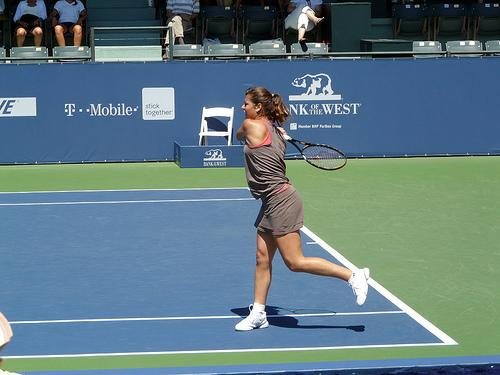Provide three details about the tennis player's outfit. The tennis player is wearing a gray tank top, a gray short skirt, and white shoes with white socks. Mention three different colors visible on the tennis court's surface. Blue, green, and white are colors visible on the tennis court's surface. Explain the natural phenomenon creating a specific feature in the picture that indicates the presence of the main character. A shadow of the woman is created due to the sunlight hitting her and being obstructed, resulting in a darker area on the ground. Describe the condition of the seating area in the image. There are spectators in the bleachers, some empty blue seats, a white folding chair, and front row seats with people watching the tennis match.  Describe the actions of the spectators in the image. The spectators are watching the tennis match from the bleachers and front row seats. Some show their knees while others are bending over. Mention a specific object in the image that has some text on it. A sign that says "stick together" is an object with text on it. Identify the sport being played in the image and provide a brief description of the main participant. The sport is tennis, and the main participant is a woman with brown hair in a ponytail, wearing a gray shorts, tank top, and white shoes, swinging her tennis racket.  Name the object(s) or environmental features in the image that are specific to a tennis game. A blue hard tennis court, the green portion of the tennis court, and a solid white line on the tennis court are specific to a tennis game. What kind of objects are besides the main human character? Name three of them. A white folding chair, a black tennis racket, and a phone company ad on the wall are besides the main human character. What is written on the banner with the logo of a phone company? Mention the company name. The banner features T-Mobile's logo, and the words "stick together" are written on it. 